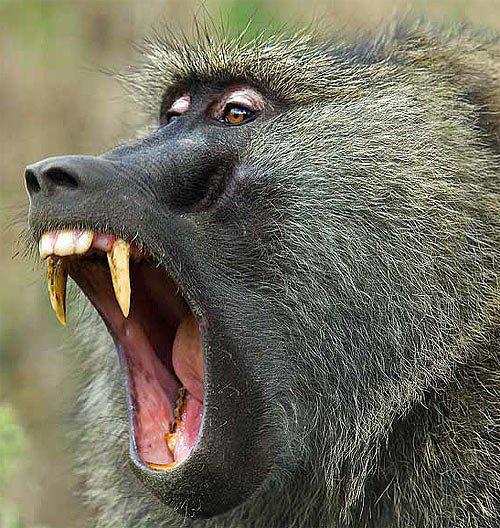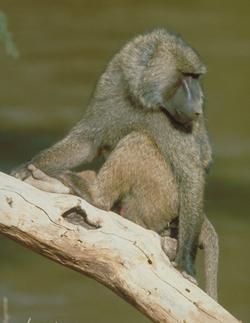The first image is the image on the left, the second image is the image on the right. Assess this claim about the two images: "One of these lesser apes is carrying a younger primate.". Correct or not? Answer yes or no. No. The first image is the image on the left, the second image is the image on the right. Evaluate the accuracy of this statement regarding the images: "a baby baboon is riding on its mothers back". Is it true? Answer yes or no. No. 